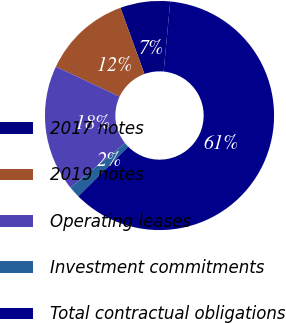Convert chart to OTSL. <chart><loc_0><loc_0><loc_500><loc_500><pie_chart><fcel>2017 notes<fcel>2019 notes<fcel>Operating leases<fcel>Investment commitments<fcel>Total contractual obligations<nl><fcel>7.04%<fcel>12.44%<fcel>17.84%<fcel>1.64%<fcel>61.04%<nl></chart> 